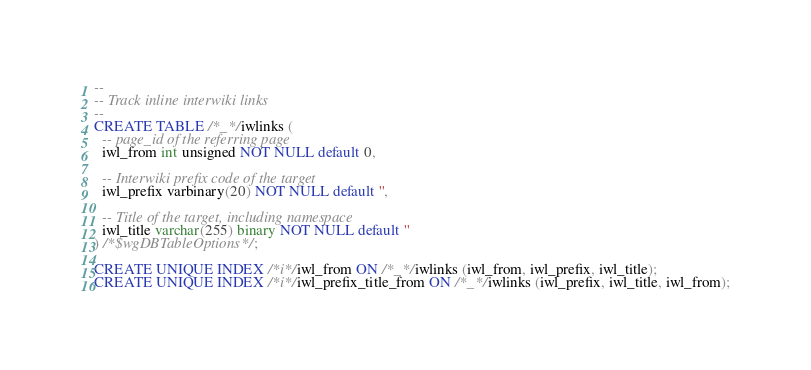Convert code to text. <code><loc_0><loc_0><loc_500><loc_500><_SQL_>-- 
-- Track inline interwiki links
--
CREATE TABLE /*_*/iwlinks (
  -- page_id of the referring page
  iwl_from int unsigned NOT NULL default 0,
  
  -- Interwiki prefix code of the target
  iwl_prefix varbinary(20) NOT NULL default '',

  -- Title of the target, including namespace
  iwl_title varchar(255) binary NOT NULL default ''
) /*$wgDBTableOptions*/;

CREATE UNIQUE INDEX /*i*/iwl_from ON /*_*/iwlinks (iwl_from, iwl_prefix, iwl_title);
CREATE UNIQUE INDEX /*i*/iwl_prefix_title_from ON /*_*/iwlinks (iwl_prefix, iwl_title, iwl_from);
</code> 